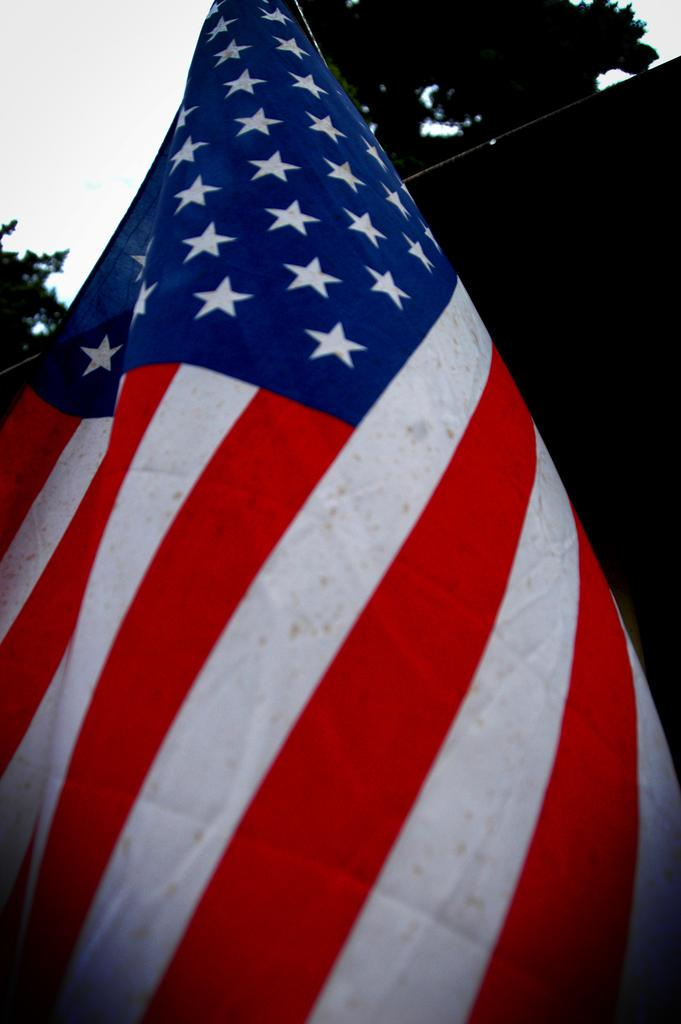What flag is present in the image? There is a United States of America national flag in the image. What can be seen in the background of the image? Trees and the sky are visible in the background of the image. What type of cart is being used to transport the flag in the image? There is no cart present in the image; the flag is simply displayed. 